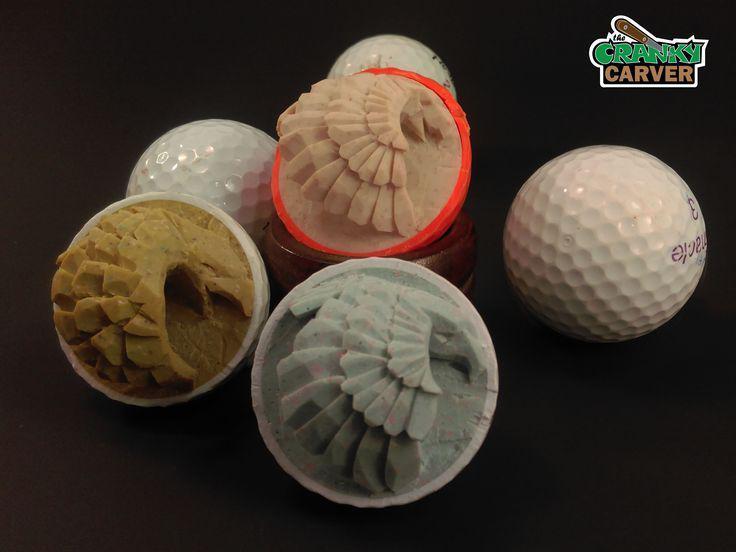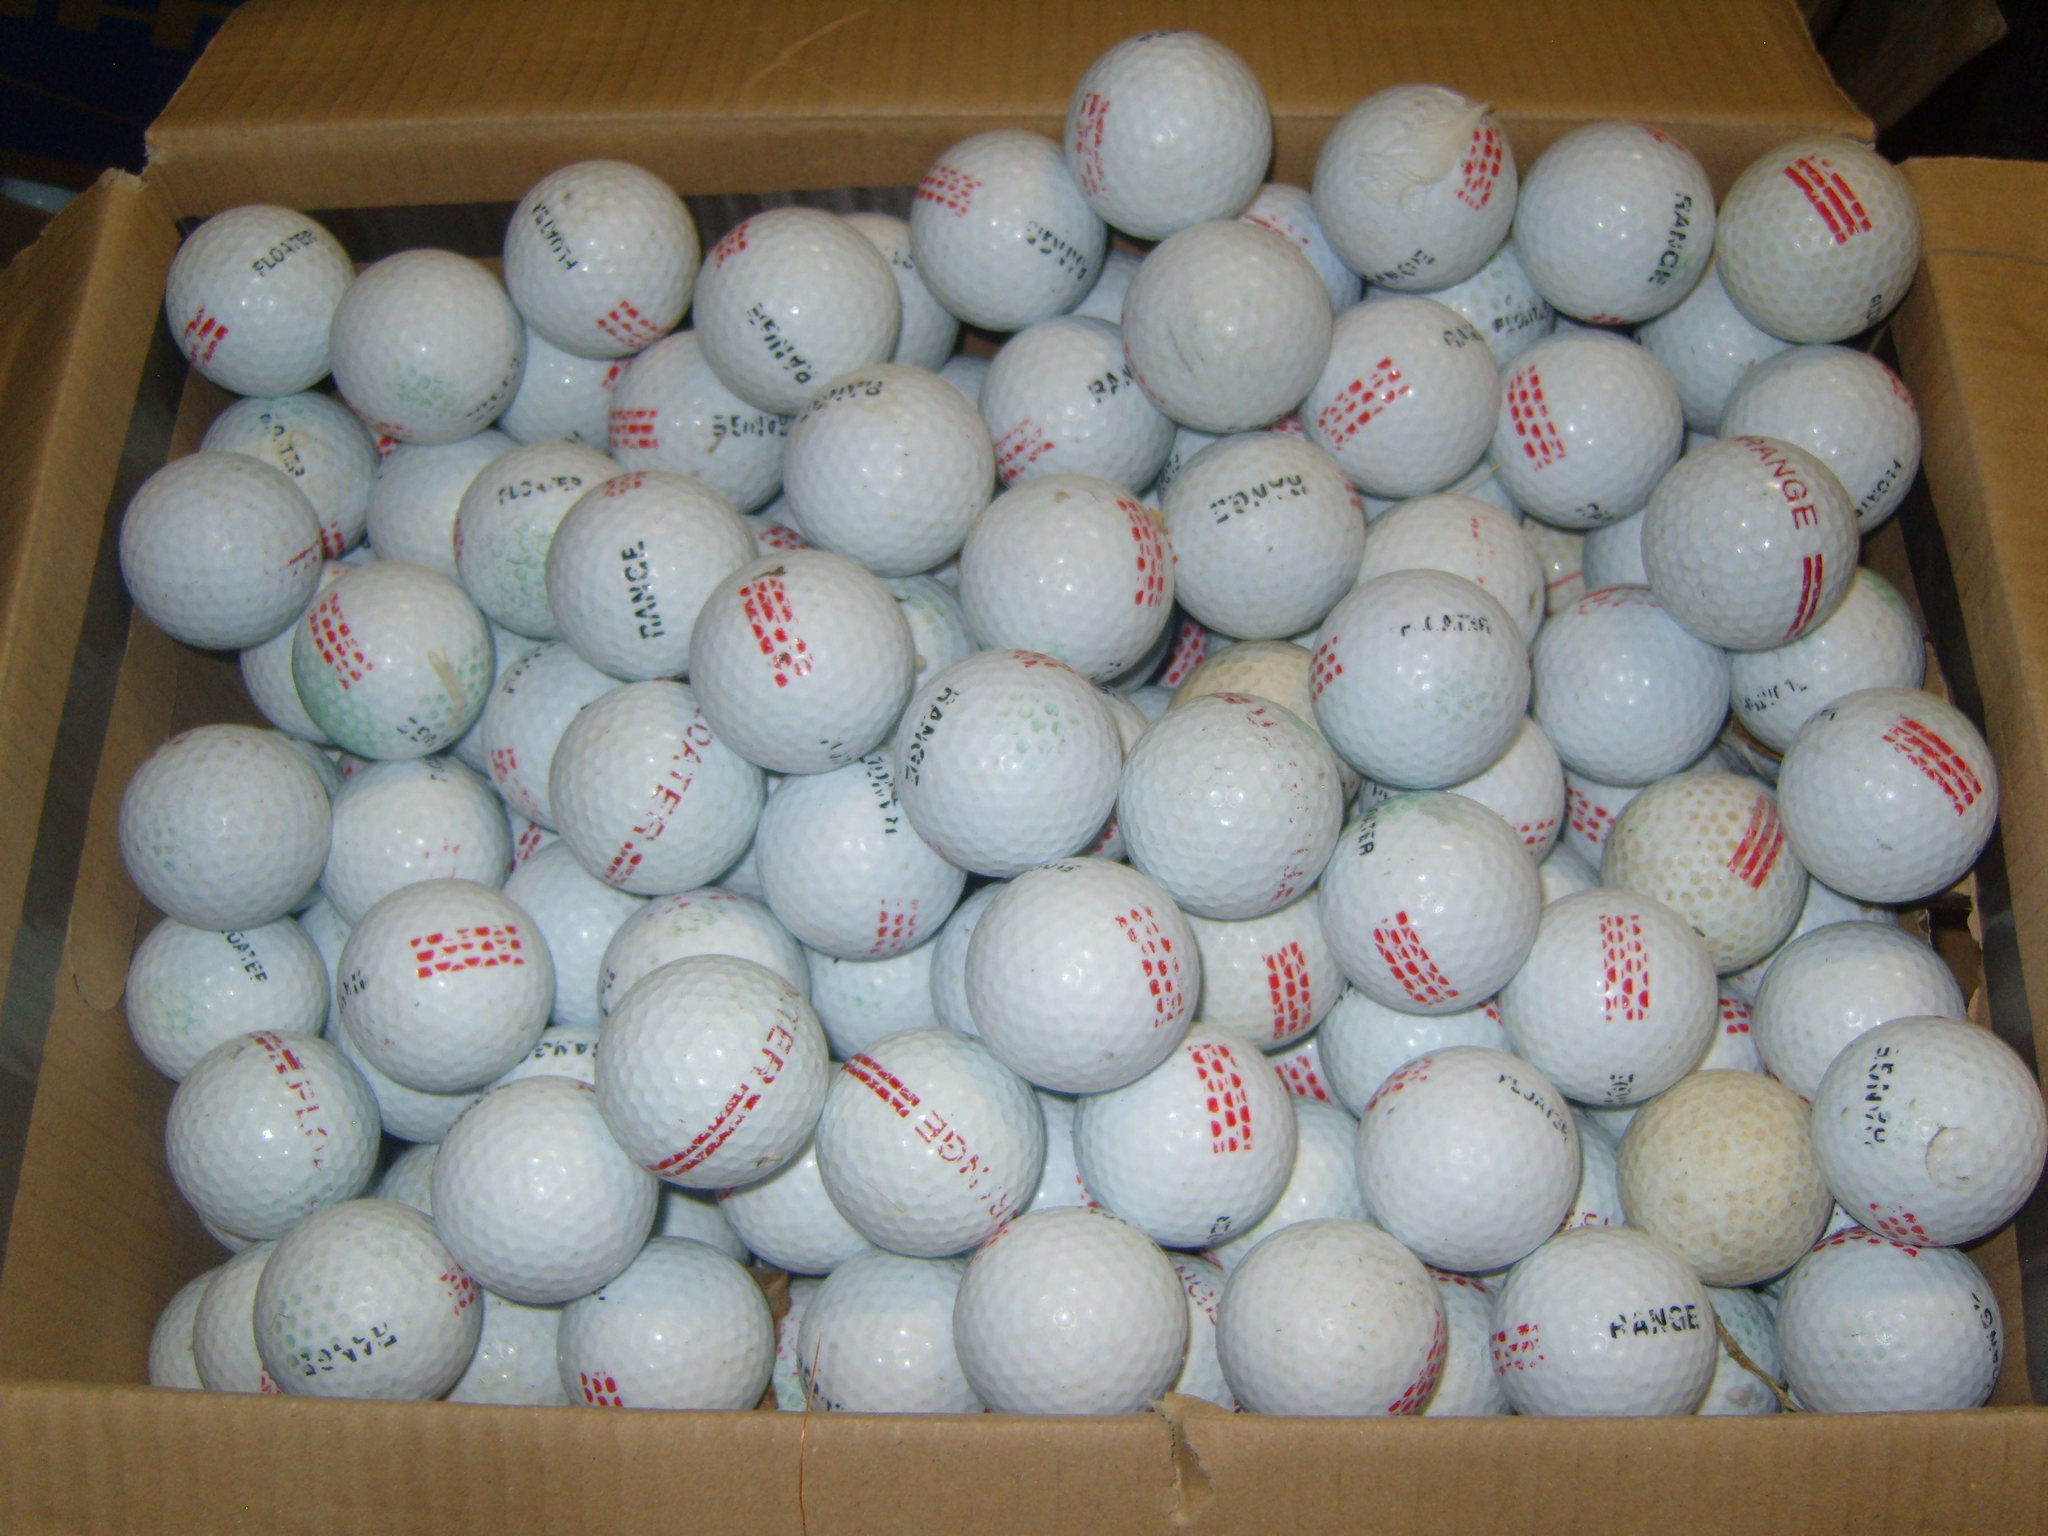The first image is the image on the left, the second image is the image on the right. Assess this claim about the two images: "Three balls are on tees in one of the images.". Correct or not? Answer yes or no. No. The first image is the image on the left, the second image is the image on the right. Analyze the images presented: Is the assertion "An image shows an angled row of three white golf balls on tees on green carpet." valid? Answer yes or no. No. 